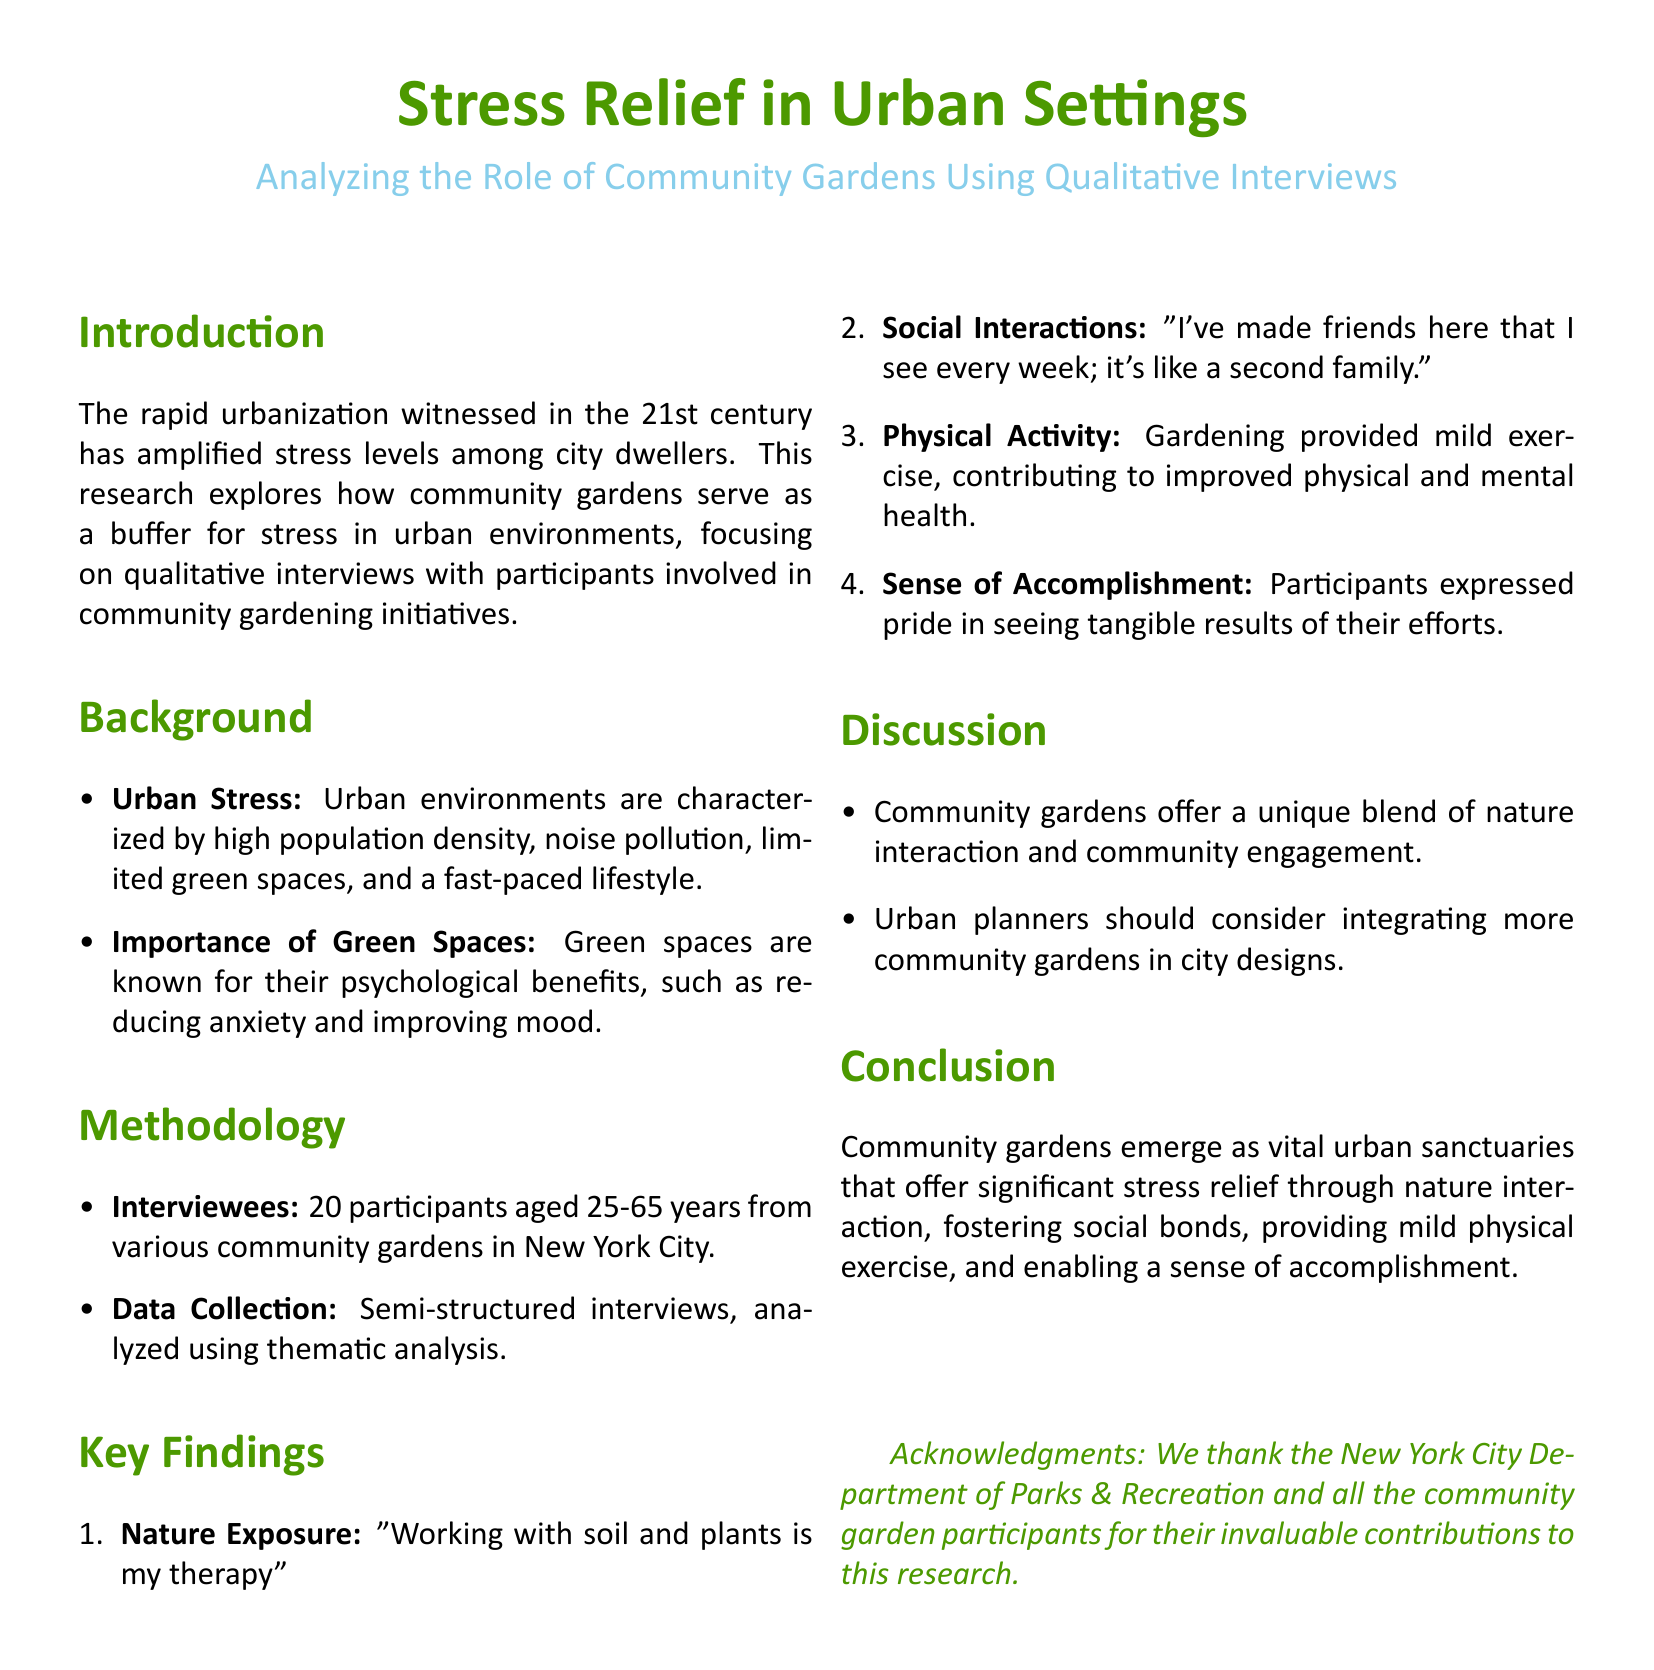What is the main focus of the research? The main focus is on how community gardens serve as a buffer for stress in urban environments.
Answer: Stress relief in urban environments How many participants were interviewed in the study? The number of participants involved in the study is explicitly mentioned in the document.
Answer: 20 What is one key psychological benefit of green spaces mentioned? The document states that green spaces are known for their psychological benefits, specifically mentioning reducing anxiety.
Answer: Reducing anxiety What age range do the participants fall into? The age range of the participants is stated in the methodology section of the document.
Answer: 25-65 years What type of analysis was used in the research? The analysis method is clearly detailed in the methodology section.
Answer: Thematic analysis What phrase did a participant use to describe the therapeutic aspect of gardening? A participant's quote regarding gardening as therapeutic is included in the key findings.
Answer: "Working with soil and plants is my therapy" What aspect of community gardens contributes to improved mental health? The physical activity involved in gardening is cited as contributing to improved mental health.
Answer: Mild exercise What type of interaction do participants experience in community gardens? The interactions experienced by participants in community gardens are highlighted in the key findings section.
Answer: Social interactions What should urban planners consider based on the discussion findings? The discussion section suggests an important consideration for urban planners regarding community gardens.
Answer: Integrating more community gardens 